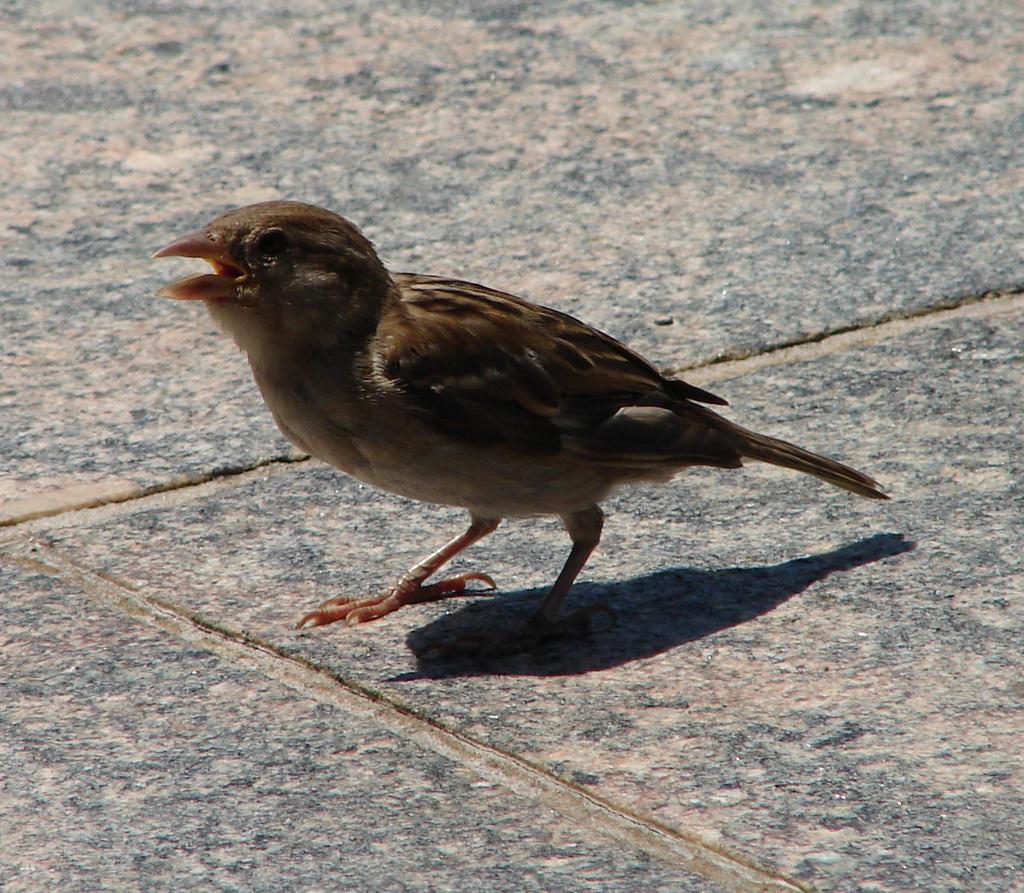In one or two sentences, can you explain what this image depicts? In this picture we can see a bird on the marble surface. 